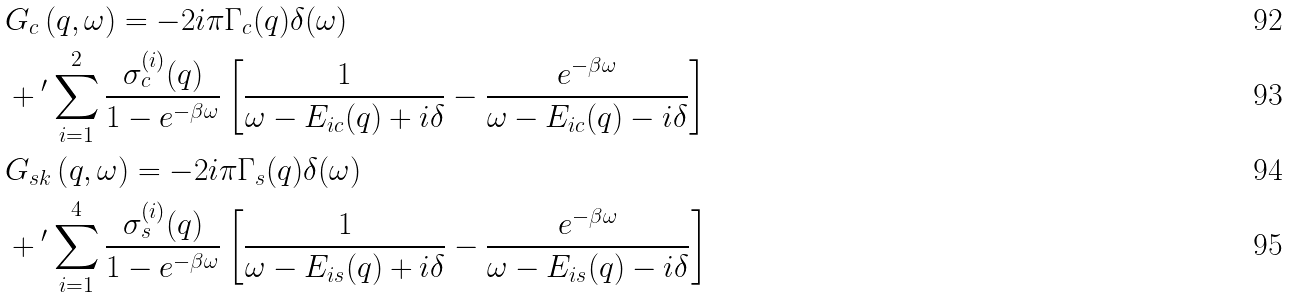Convert formula to latex. <formula><loc_0><loc_0><loc_500><loc_500>& G _ { c } \left ( q , \omega \right ) = - 2 i \pi \Gamma _ { c } ( q ) \delta ( \omega ) \\ & + { ^ { \prime } } \sum _ { i = 1 } ^ { 2 } \frac { \sigma _ { c } ^ { ( i ) } ( q ) } { 1 - e ^ { - \beta \omega } } \left [ \frac { 1 } { \omega - E _ { i c } ( q ) + i \delta } - \frac { e ^ { - \beta \omega } } { \omega - E _ { i c } ( q ) - i \delta } \right ] \\ & G _ { s k } \left ( q , \omega \right ) = - 2 i \pi \Gamma _ { s } ( q ) \delta ( \omega ) \\ & + { ^ { \prime } } \sum _ { i = 1 } ^ { 4 } \frac { \sigma _ { s } ^ { ( i ) } ( q ) } { 1 - e ^ { - \beta \omega } } \left [ \frac { 1 } { \omega - E _ { i s } ( q ) + i \delta } - \frac { e ^ { - \beta \omega } } { \omega - E _ { i s } ( q ) - i \delta } \right ]</formula> 